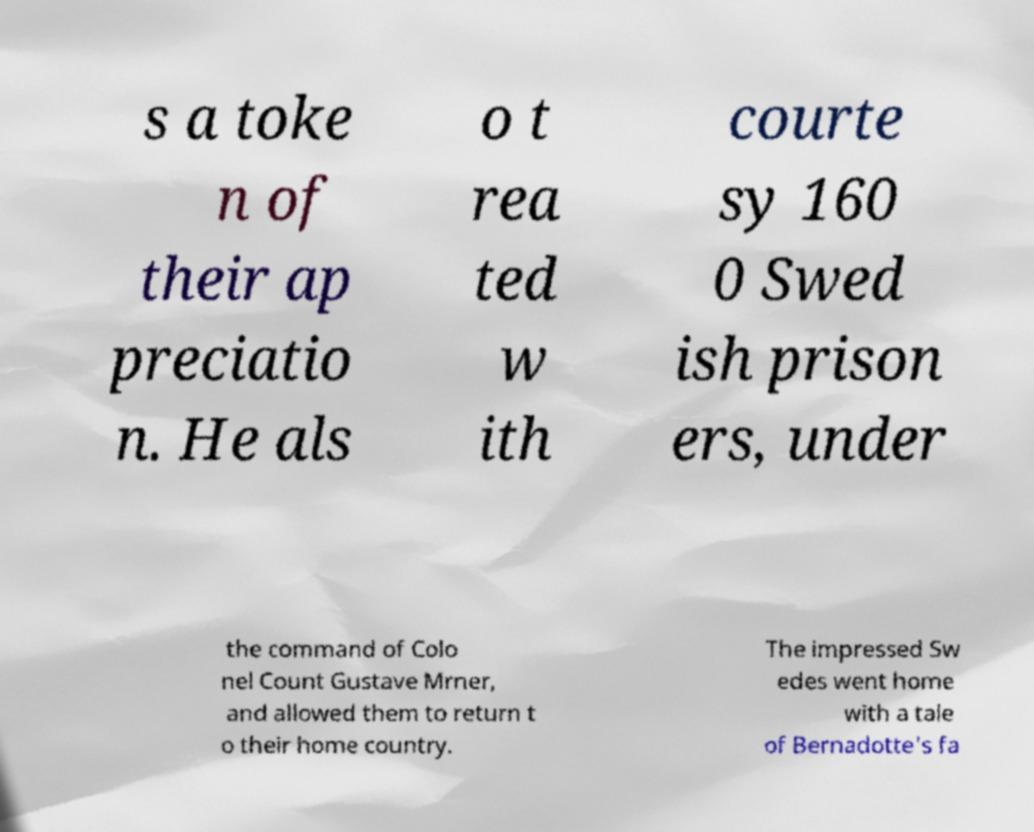What messages or text are displayed in this image? I need them in a readable, typed format. s a toke n of their ap preciatio n. He als o t rea ted w ith courte sy 160 0 Swed ish prison ers, under the command of Colo nel Count Gustave Mrner, and allowed them to return t o their home country. The impressed Sw edes went home with a tale of Bernadotte's fa 